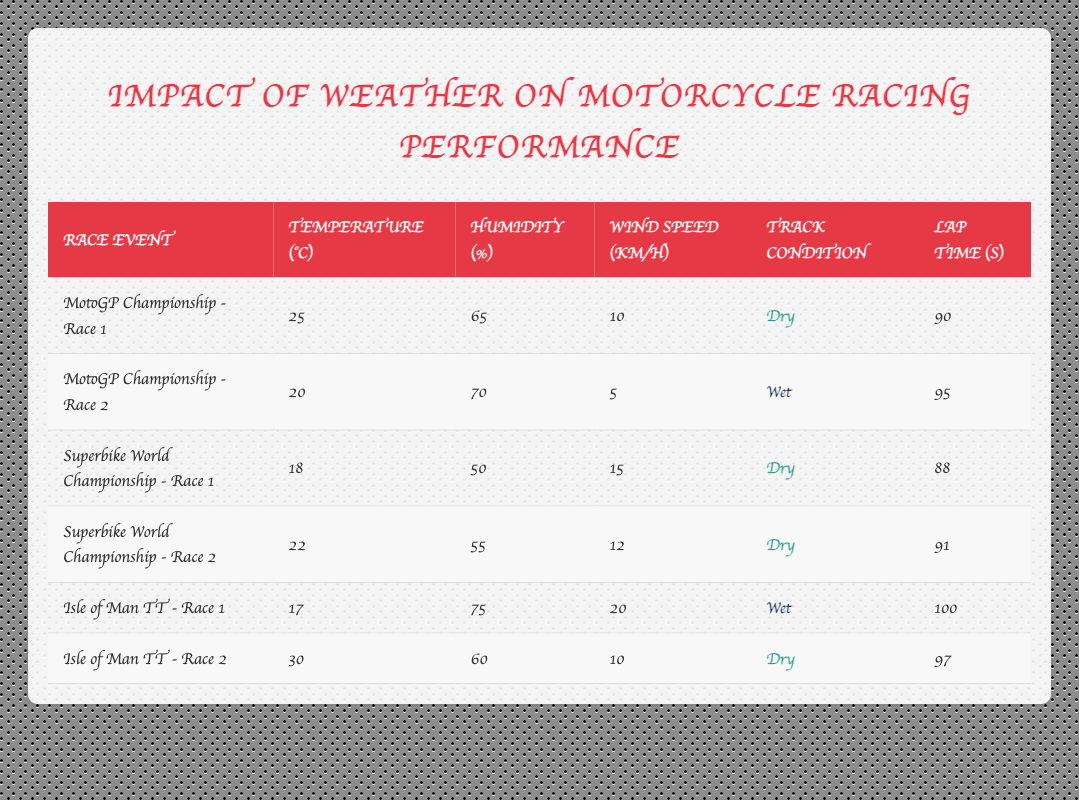What is the lap time for the "Superbike World Championship - Race 1"? The table shows the lap time for each race event. For "Superbike World Championship - Race 1," the lap time is listed as 88 seconds.
Answer: 88 seconds What was the wind speed during "Isle of Man TT - Race 1"? Referring to the table, "Isle of Man TT - Race 1" displays a wind speed of 20 km/h.
Answer: 20 km/h Which race event had the highest humidity percentage? By comparing the humidity percentages in the table, "Isle of Man TT - Race 1" has the highest humidity, at 75 percent.
Answer: Isle of Man TT - Race 1 What is the average lap time for races in dry track conditions? The lap times for dry conditions are 90, 88, 91, and 97 seconds. Adding these gives 90 + 88 + 91 + 97 = 366 seconds. There are 4 races, so the average is 366/4 = 91.5 seconds.
Answer: 91.5 seconds Did the "MotoGP Championship - Race 2" take place on a dry track? The track condition for "MotoGP Championship - Race 2" is indicated as wet in the table, therefore, the answer is no.
Answer: No What is the difference in lap time between "Isle of Man TT - Race 1" and "Isle of Man TT - Race 2"? "Isle of Man TT - Race 1" has a lap time of 100 seconds, and "Isle of Man TT - Race 2" has a lap time of 97 seconds. The difference is 100 - 97 = 3 seconds.
Answer: 3 seconds What was the temperature during "Superbike World Championship - Race 2"? Looking at the table, "Superbike World Championship - Race 2" shows a temperature of 22 degrees Celsius.
Answer: 22 degrees Celsius How many race events were held under wet track conditions? The table provides two events with wet conditions: "MotoGP Championship - Race 2" and "Isle of Man TT - Race 1." Thus, there are 2 events in wet conditions.
Answer: 2 